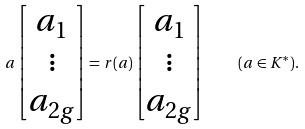<formula> <loc_0><loc_0><loc_500><loc_500>a \left [ \begin{matrix} a _ { 1 } \\ \vdots \\ a _ { 2 g } \end{matrix} \right ] = r ( a ) \left [ \begin{matrix} a _ { 1 } \\ \vdots \\ a _ { 2 g } \end{matrix} \right ] \quad ( a \in K ^ { * } ) .</formula> 